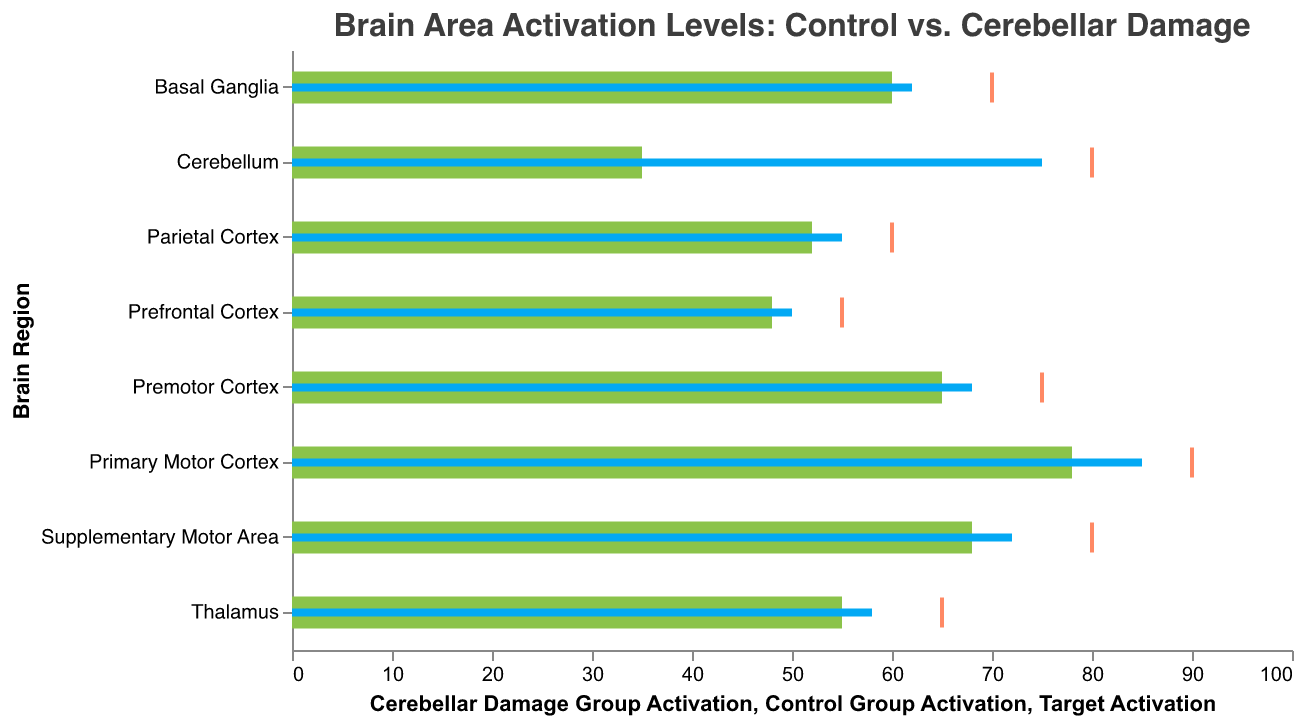What is the title of the figure? The title of the figure is shown at the top and reads "Brain Area Activation Levels: Control vs. Cerebellar Damage".
Answer: Brain Area Activation Levels: Control vs. Cerebellar Damage Which brain region has the highest activation level in the control group? To find this, observe the bars representing the control group (blue bars). The longest bar corresponds to the "Primary Motor Cortex," indicating it has the highest activation level.
Answer: Primary Motor Cortex How much lower is the activation level in the cerebellar damage group compared to the control group for the Cerebellum region? For the Cerebellum, the control group has an activation level of 75, while the cerebellar damage group has 35. The difference is calculated as 75 - 35.
Answer: 40 What is the target activation level for the Thalamus? The target activation level for the Thalamus can be identified by locating the tick mark on its row, which points to the value 65 on the x-axis.
Answer: 65 Which brain region has the closest activation level between the control and cerebellar damage groups? Analyze the difference between the bars of the control group and cerebellar damage group for each brain region. The Basal Ganglia region shows a control group activation of 62 and cerebellar damage group activation of 60, indicating the smallest difference of 2 units.
Answer: Basal Ganglia What is the average activation level for the control group across all brain regions? First, sum all the control group activation levels: 85+72+68+62+58+75+55+50 = 525. Then, divide by the number of brain regions (8): 525/8.
Answer: 65.625 Which brain region displays the largest decrease in activation levels when comparing the control group to the cerebellar damage group? Compare the differences for each brain region. The largest decrease is observed in the Cerebellum, where the control group is at 75 and the cerebellar damage group is at 35, resulting in a decrease of 40.
Answer: Cerebellum Is the activation level in the cerebellar damage group for the Parietal Cortex above or below the target activation level? For the Parietal Cortex, the cerebellar damage group activation level is 52, and the target activation level is 60. Since 52 is less than 60, it's below the target activation level.
Answer: Below Which brain region falls the farthest short of its target activation level in the cerebellar damage group? Compare the target and cerebellar damage group activation levels. The Cerebellum shows the biggest shortfall, with a target of 80 and an actual activation level of 35, resulting in a shortfall of 45.
Answer: Cerebellum 